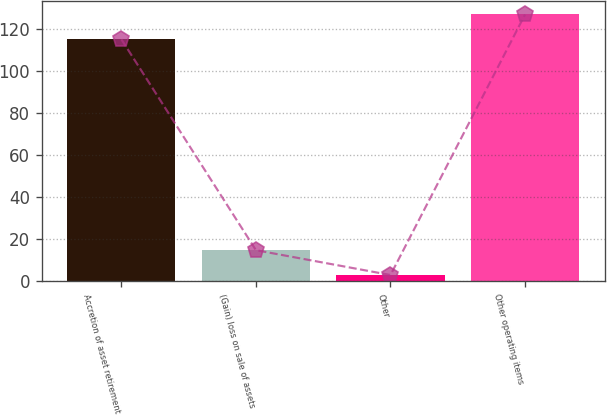<chart> <loc_0><loc_0><loc_500><loc_500><bar_chart><fcel>Accretion of asset retirement<fcel>(Gain) loss on sale of assets<fcel>Other<fcel>Other operating items<nl><fcel>115<fcel>14.8<fcel>3<fcel>126.8<nl></chart> 